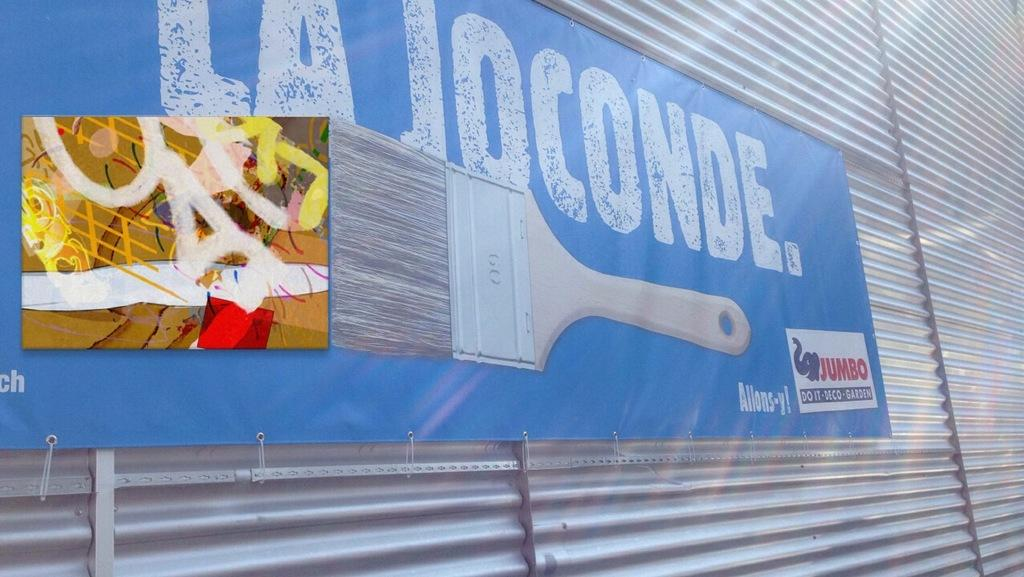<image>
Give a short and clear explanation of the subsequent image. Blue sign on the wall with the words "La Joconde" and a paintbrush. 